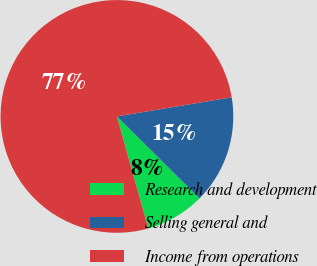Convert chart to OTSL. <chart><loc_0><loc_0><loc_500><loc_500><pie_chart><fcel>Research and development<fcel>Selling general and<fcel>Income from operations<nl><fcel>8.22%<fcel>15.07%<fcel>76.71%<nl></chart> 